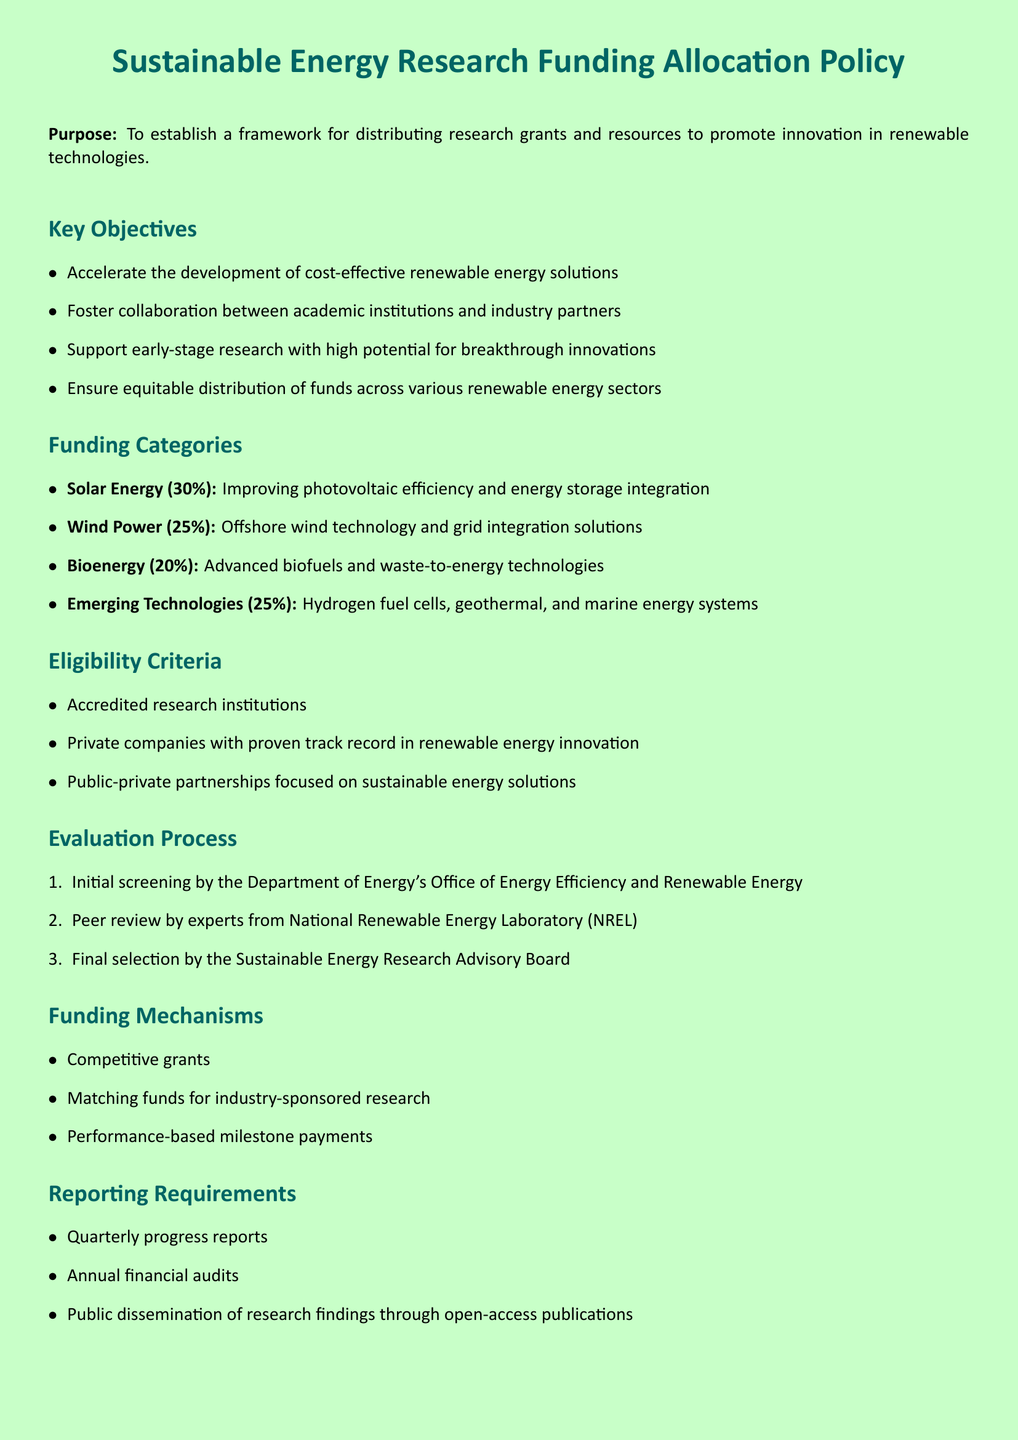What is the main purpose of the policy? The purpose is to establish a framework for distributing research grants and resources to promote innovation in renewable technologies.
Answer: To establish a framework for distributing research grants and resources to promote innovation in renewable technologies How much funding is allocated to Wind Power? The percentage of funding allocated to Wind Power is stated in the funding categories section.
Answer: 25% What are the eligibility criteria for research funding? The document outlines the three eligibility criteria that must be met by applicants.
Answer: Accredited research institutions, private companies, public-private partnerships Who conducts the peer review in the evaluation process? The peer review is conducted by experts from an organization mentioned in the evaluation section.
Answer: National Renewable Energy Laboratory What type of reports are required quarterly? The document specifies the type of report that needs to be submitted every quarter as part of the reporting requirements.
Answer: Progress reports What is the total percentage allocated for Solar Energy and Bioenergy combined? The total percentage is the sum of the individual allocations for these two categories.
Answer: 50% What initiative is mentioned for fostering collaboration? The document lists a specific annual event aimed at bringing together stakeholders in sustainable energy.
Answer: Annual Sustainable Energy Innovation Summit Which performance indicator relates to commercialization? The key performance indicator mentioned that assesses the success of innovations.
Answer: Successfully commercialized innovations 